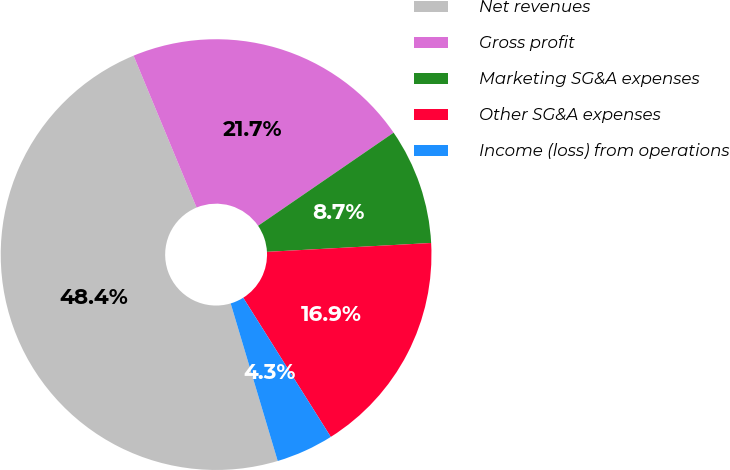Convert chart. <chart><loc_0><loc_0><loc_500><loc_500><pie_chart><fcel>Net revenues<fcel>Gross profit<fcel>Marketing SG&A expenses<fcel>Other SG&A expenses<fcel>Income (loss) from operations<nl><fcel>48.36%<fcel>21.68%<fcel>8.72%<fcel>16.92%<fcel>4.32%<nl></chart> 